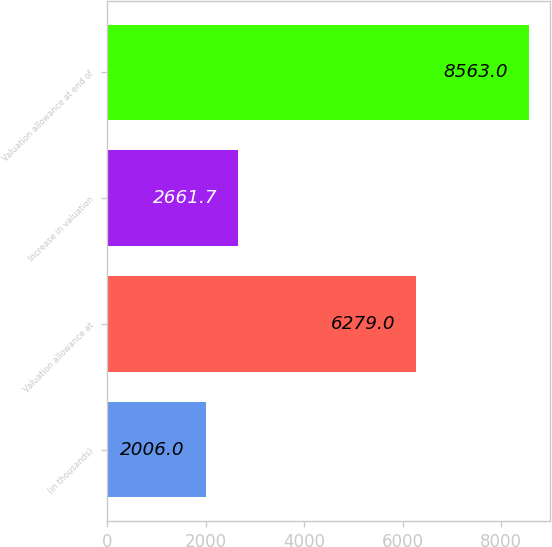Convert chart. <chart><loc_0><loc_0><loc_500><loc_500><bar_chart><fcel>(in thousands)<fcel>Valuation allowance at<fcel>Increase in valuation<fcel>Valuation allowance at end of<nl><fcel>2006<fcel>6279<fcel>2661.7<fcel>8563<nl></chart> 